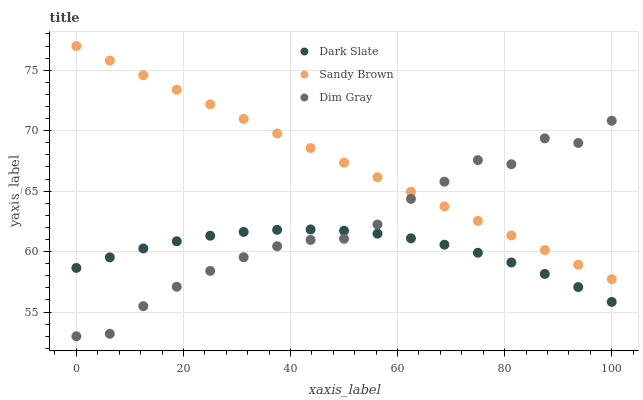Does Dark Slate have the minimum area under the curve?
Answer yes or no. Yes. Does Sandy Brown have the maximum area under the curve?
Answer yes or no. Yes. Does Dim Gray have the minimum area under the curve?
Answer yes or no. No. Does Dim Gray have the maximum area under the curve?
Answer yes or no. No. Is Sandy Brown the smoothest?
Answer yes or no. Yes. Is Dim Gray the roughest?
Answer yes or no. Yes. Is Dim Gray the smoothest?
Answer yes or no. No. Is Sandy Brown the roughest?
Answer yes or no. No. Does Dim Gray have the lowest value?
Answer yes or no. Yes. Does Sandy Brown have the lowest value?
Answer yes or no. No. Does Sandy Brown have the highest value?
Answer yes or no. Yes. Does Dim Gray have the highest value?
Answer yes or no. No. Is Dark Slate less than Sandy Brown?
Answer yes or no. Yes. Is Sandy Brown greater than Dark Slate?
Answer yes or no. Yes. Does Dim Gray intersect Dark Slate?
Answer yes or no. Yes. Is Dim Gray less than Dark Slate?
Answer yes or no. No. Is Dim Gray greater than Dark Slate?
Answer yes or no. No. Does Dark Slate intersect Sandy Brown?
Answer yes or no. No. 